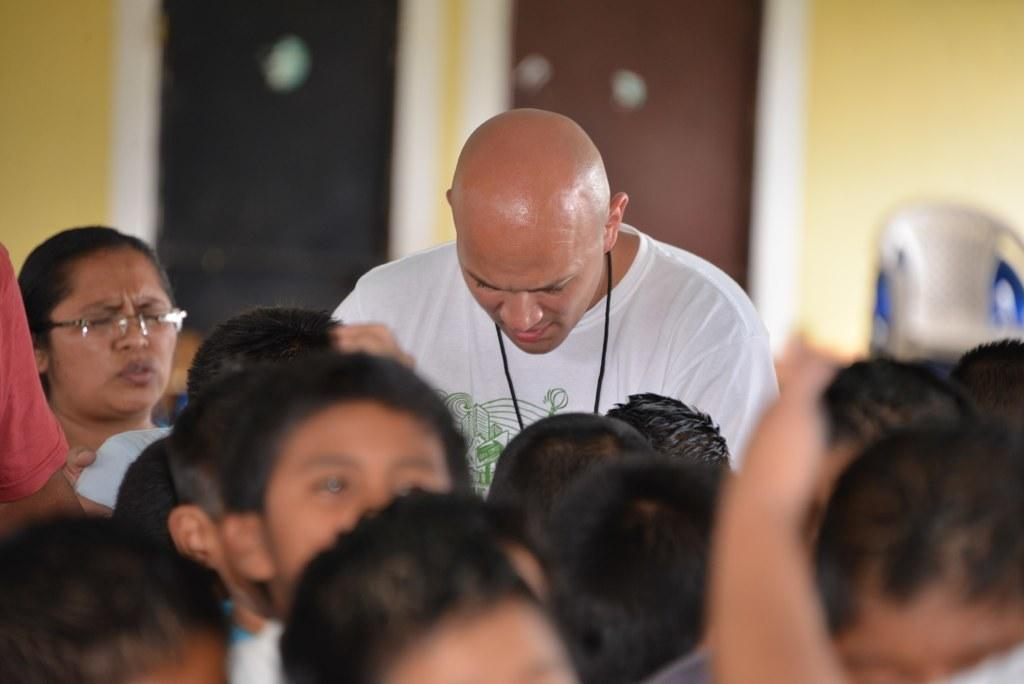What is the person in the image wearing? The person is wearing a white shirt in the image. What is the position of the person in the image? The person is standing in the image. Who is in front of the person? There are kids in front of the person. Where is the woman located in the image? The woman is in the left corner of the image. What type of reaction can be seen from the tent in the image? There is no tent present in the image, so it is not possible to observe any reaction from it. 